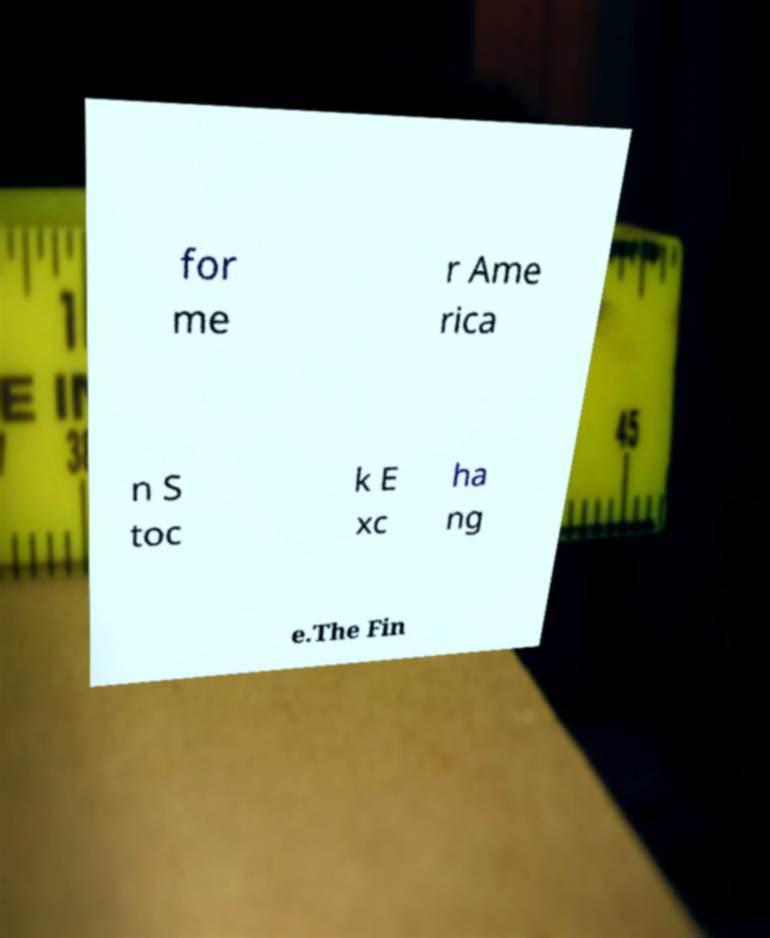Please read and relay the text visible in this image. What does it say? for me r Ame rica n S toc k E xc ha ng e.The Fin 